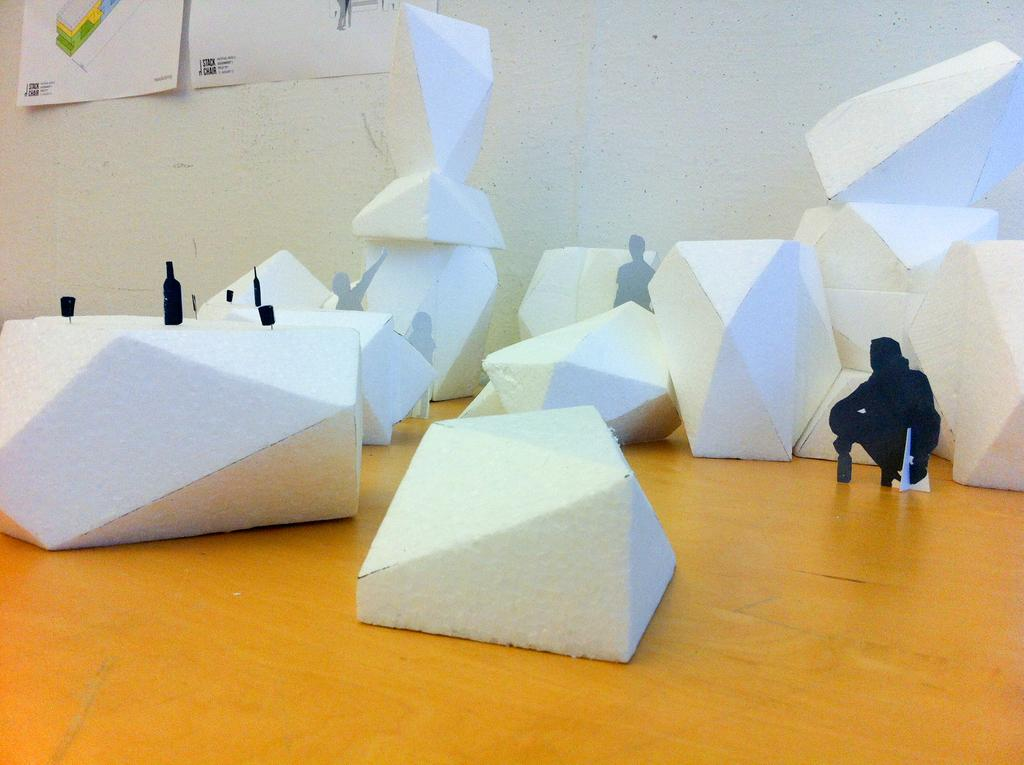What color are the objects in the image? The objects in the image are white. What is the surface on which the white objects are placed? The white objects are on a wooden surface. Can you describe any architectural features in the background of the image? Yes, there are two posts attached to a wall in the background of the image. What type of hat is being worn by the pen in the image? There is no hat or pen present in the image. 